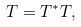<formula> <loc_0><loc_0><loc_500><loc_500>T & = T ^ { * } T ,</formula> 